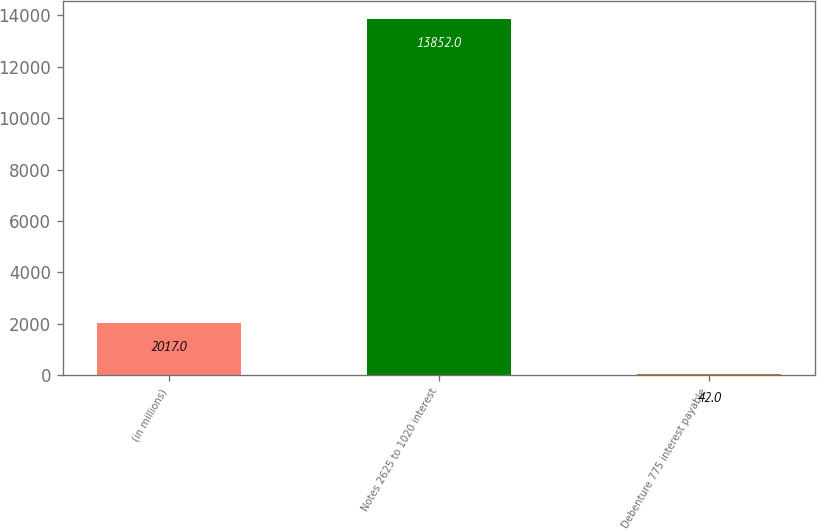Convert chart to OTSL. <chart><loc_0><loc_0><loc_500><loc_500><bar_chart><fcel>(in millions)<fcel>Notes 2625 to 1020 interest<fcel>Debenture 775 interest payable<nl><fcel>2017<fcel>13852<fcel>42<nl></chart> 